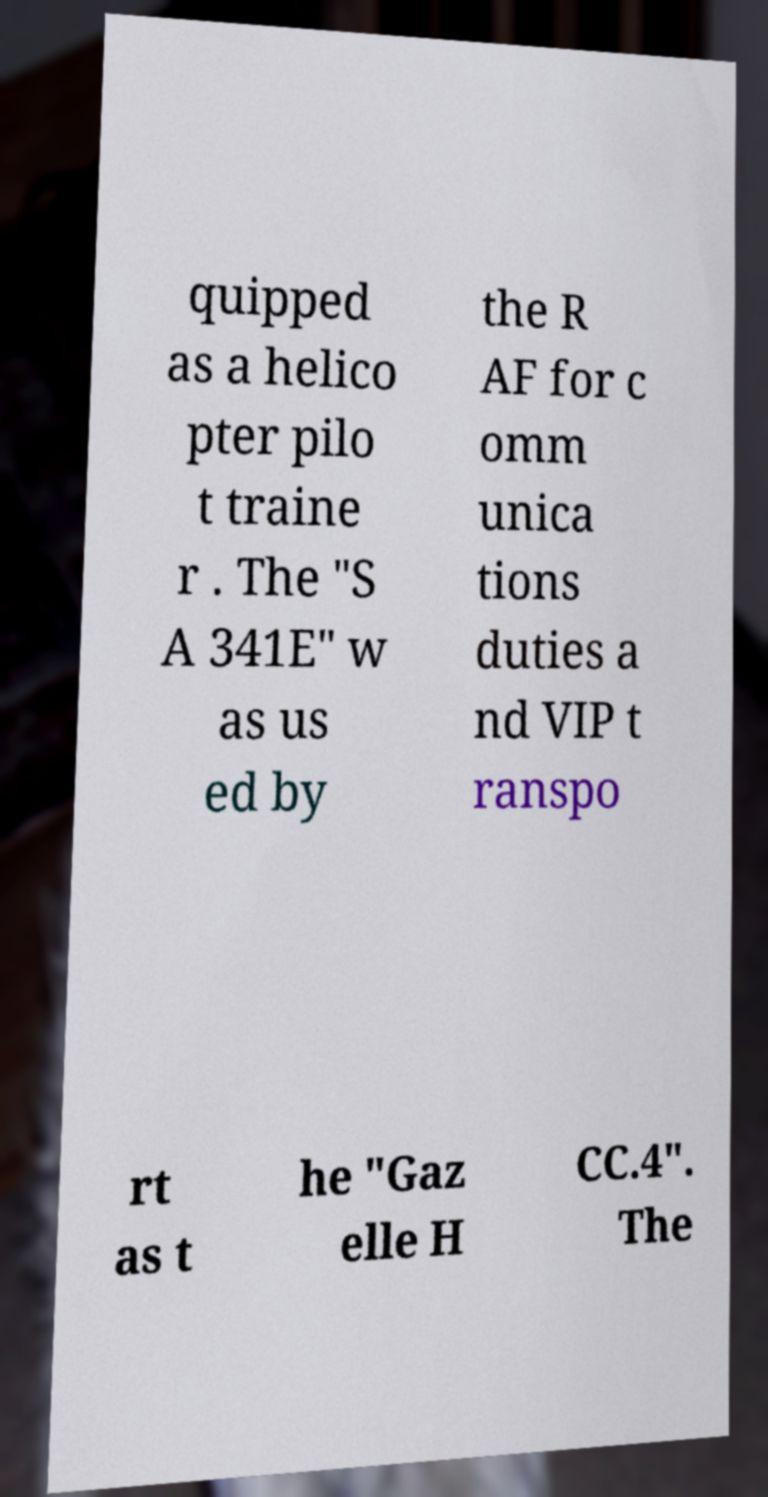Please read and relay the text visible in this image. What does it say? quipped as a helico pter pilo t traine r . The "S A 341E" w as us ed by the R AF for c omm unica tions duties a nd VIP t ranspo rt as t he "Gaz elle H CC.4". The 